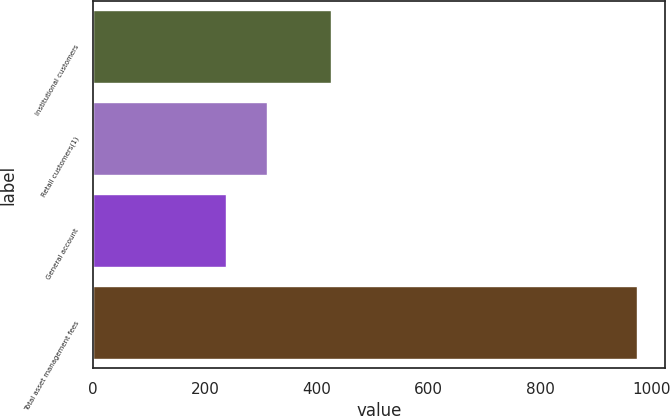<chart> <loc_0><loc_0><loc_500><loc_500><bar_chart><fcel>Institutional customers<fcel>Retail customers(1)<fcel>General account<fcel>Total asset management fees<nl><fcel>426<fcel>311.6<fcel>238<fcel>974<nl></chart> 